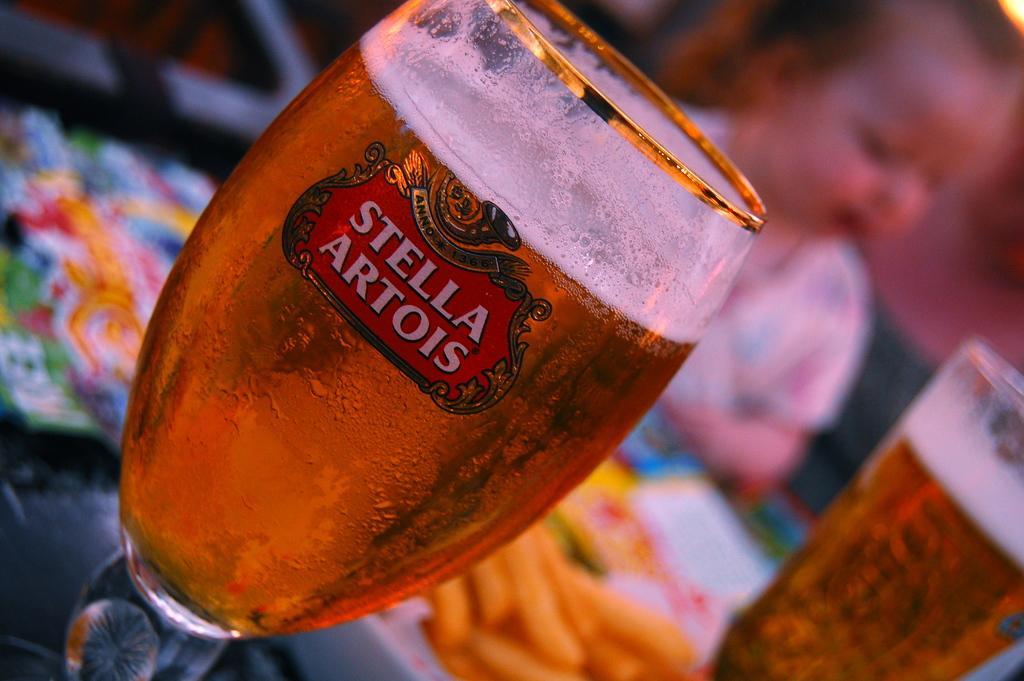Could you give a brief overview of what you see in this image? Background portion of the picture is blurry and we can see a kid. In this picture we can see the drinks in the glasses. Remaining portion of the picture is blurry and its colorful. 